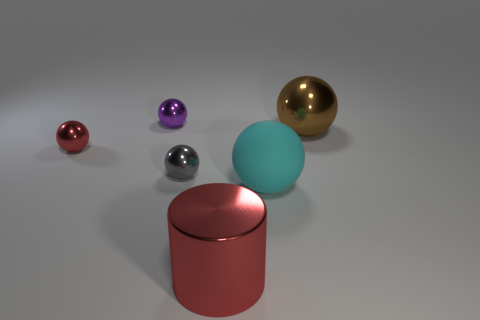Subtract all big brown shiny balls. How many balls are left? 4 Subtract all brown spheres. How many spheres are left? 4 Add 3 small metallic spheres. How many objects exist? 9 Subtract all red spheres. Subtract all cyan blocks. How many spheres are left? 4 Subtract all spheres. How many objects are left? 1 Add 3 tiny cyan metallic cubes. How many tiny cyan metallic cubes exist? 3 Subtract 0 green cylinders. How many objects are left? 6 Subtract all small brown matte spheres. Subtract all big cyan matte balls. How many objects are left? 5 Add 6 purple metal spheres. How many purple metal spheres are left? 7 